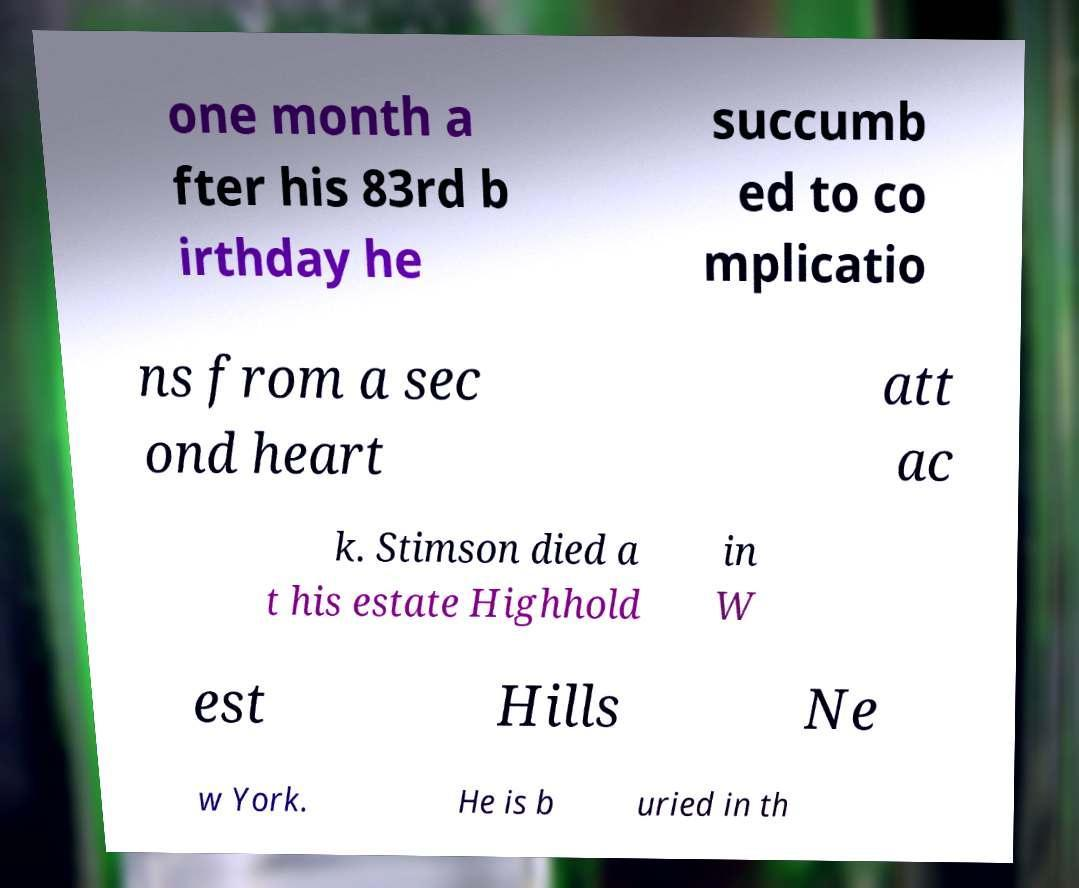For documentation purposes, I need the text within this image transcribed. Could you provide that? one month a fter his 83rd b irthday he succumb ed to co mplicatio ns from a sec ond heart att ac k. Stimson died a t his estate Highhold in W est Hills Ne w York. He is b uried in th 